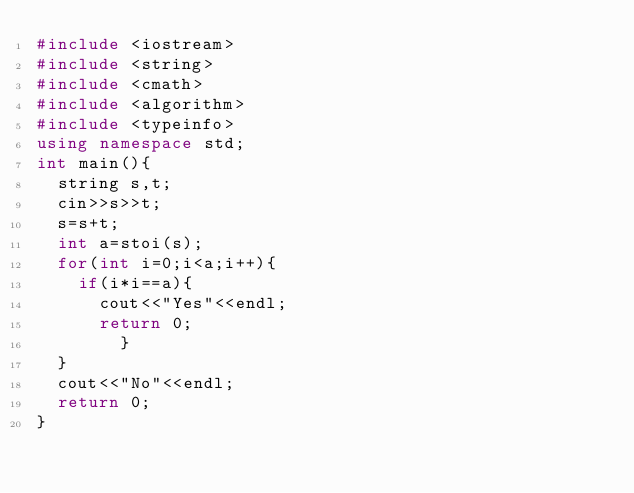<code> <loc_0><loc_0><loc_500><loc_500><_C++_>#include <iostream>
#include <string>
#include <cmath>
#include <algorithm>
#include <typeinfo>
using namespace std;
int main(){
	string s,t;
	cin>>s>>t;
	s=s+t;
	int a=stoi(s);
	for(int i=0;i<a;i++){
		if(i*i==a){
			cout<<"Yes"<<endl;
			return 0;
        }
	}
	cout<<"No"<<endl;
	return 0;
}</code> 